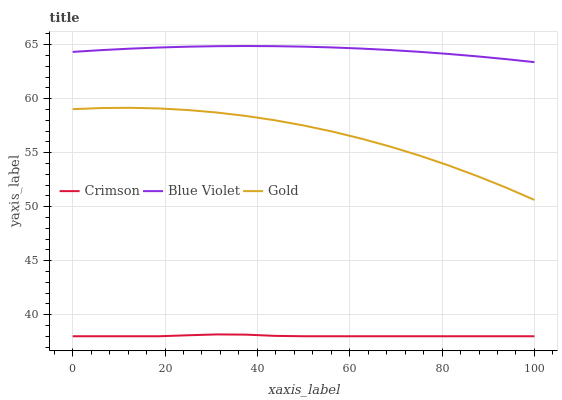Does Gold have the minimum area under the curve?
Answer yes or no. No. Does Gold have the maximum area under the curve?
Answer yes or no. No. Is Blue Violet the smoothest?
Answer yes or no. No. Is Blue Violet the roughest?
Answer yes or no. No. Does Gold have the lowest value?
Answer yes or no. No. Does Gold have the highest value?
Answer yes or no. No. Is Crimson less than Gold?
Answer yes or no. Yes. Is Gold greater than Crimson?
Answer yes or no. Yes. Does Crimson intersect Gold?
Answer yes or no. No. 